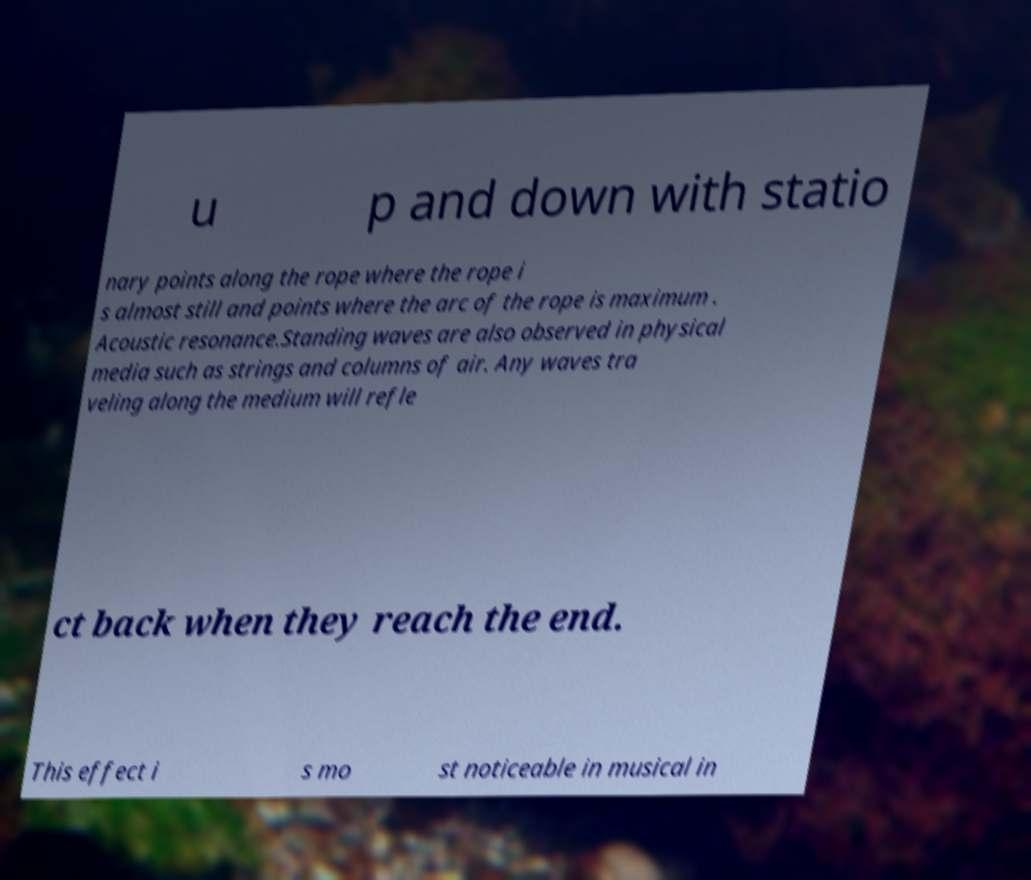Please identify and transcribe the text found in this image. u p and down with statio nary points along the rope where the rope i s almost still and points where the arc of the rope is maximum . Acoustic resonance.Standing waves are also observed in physical media such as strings and columns of air. Any waves tra veling along the medium will refle ct back when they reach the end. This effect i s mo st noticeable in musical in 